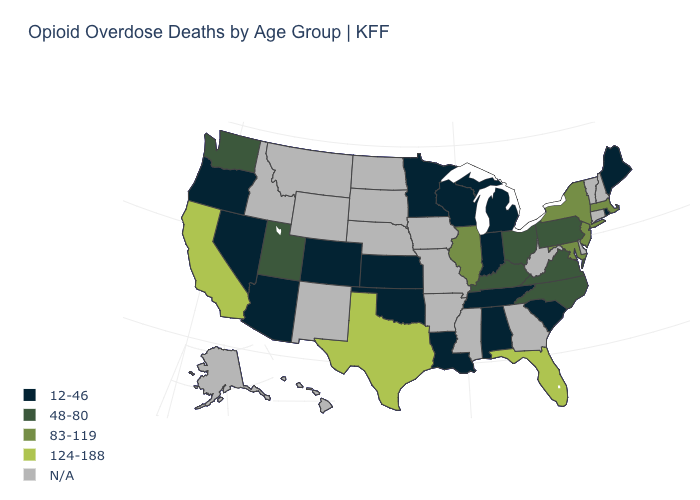What is the highest value in the USA?
Give a very brief answer. 124-188. How many symbols are there in the legend?
Keep it brief. 5. Is the legend a continuous bar?
Short answer required. No. What is the value of California?
Keep it brief. 124-188. Name the states that have a value in the range 12-46?
Give a very brief answer. Alabama, Arizona, Colorado, Indiana, Kansas, Louisiana, Maine, Michigan, Minnesota, Nevada, Oklahoma, Oregon, Rhode Island, South Carolina, Tennessee, Wisconsin. Is the legend a continuous bar?
Short answer required. No. Which states hav the highest value in the MidWest?
Write a very short answer. Illinois. What is the lowest value in the MidWest?
Give a very brief answer. 12-46. Does Oregon have the lowest value in the USA?
Be succinct. Yes. What is the value of New Mexico?
Answer briefly. N/A. Among the states that border Wyoming , which have the highest value?
Answer briefly. Utah. Does the first symbol in the legend represent the smallest category?
Write a very short answer. Yes. What is the value of Montana?
Short answer required. N/A. Does the map have missing data?
Give a very brief answer. Yes. Is the legend a continuous bar?
Short answer required. No. 